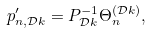<formula> <loc_0><loc_0><loc_500><loc_500>p _ { n , \mathcal { D } k } ^ { \prime } = P _ { \mathcal { D } k } ^ { - 1 } \Theta _ { n } ^ { \left ( \mathcal { D } k \right ) } ,</formula> 